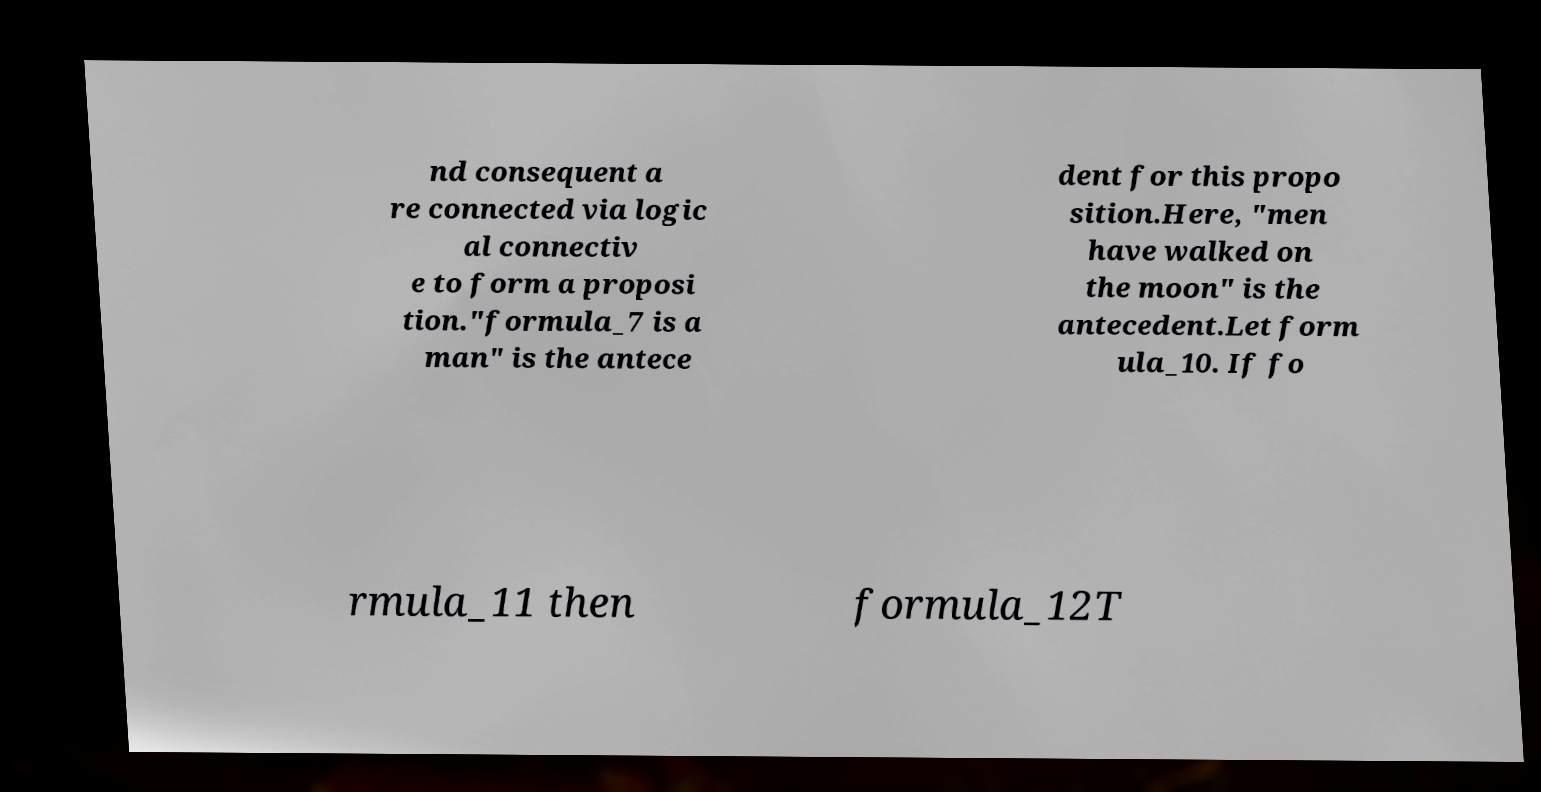Could you extract and type out the text from this image? nd consequent a re connected via logic al connectiv e to form a proposi tion."formula_7 is a man" is the antece dent for this propo sition.Here, "men have walked on the moon" is the antecedent.Let form ula_10. If fo rmula_11 then formula_12T 